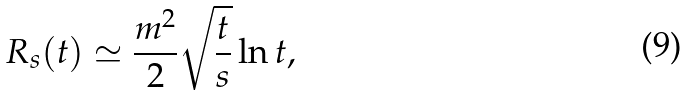<formula> <loc_0><loc_0><loc_500><loc_500>R _ { s } ( t ) \simeq \frac { m ^ { 2 } } { 2 } \sqrt { \frac { t } { s } } \ln t ,</formula> 